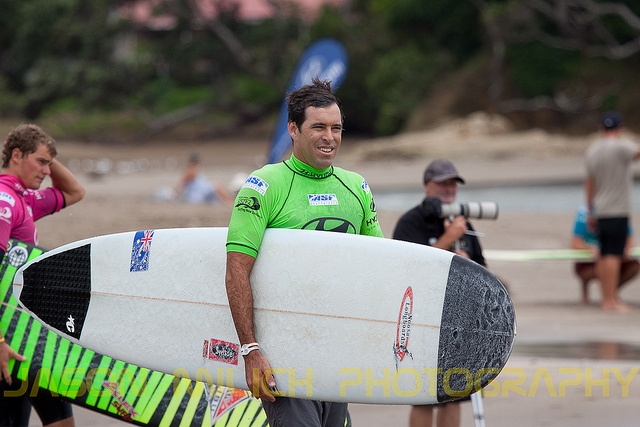Describe the objects in this image and their specific colors. I can see surfboard in black, lightgray, darkgray, and gray tones, people in black, lightgreen, and brown tones, surfboard in black, lightgreen, and purple tones, people in black, brown, purple, and maroon tones, and people in black, gray, and darkgray tones in this image. 